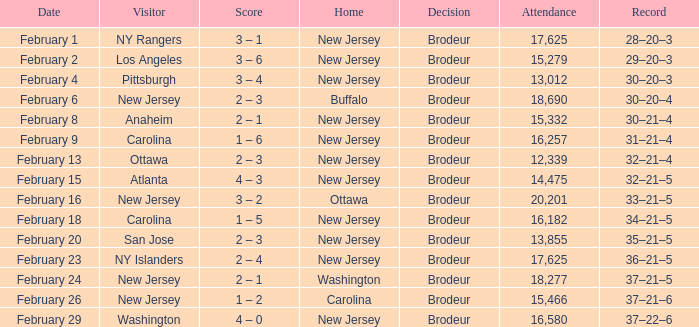What was the score when the ny islanders played as the visiting team? 2 – 4. 